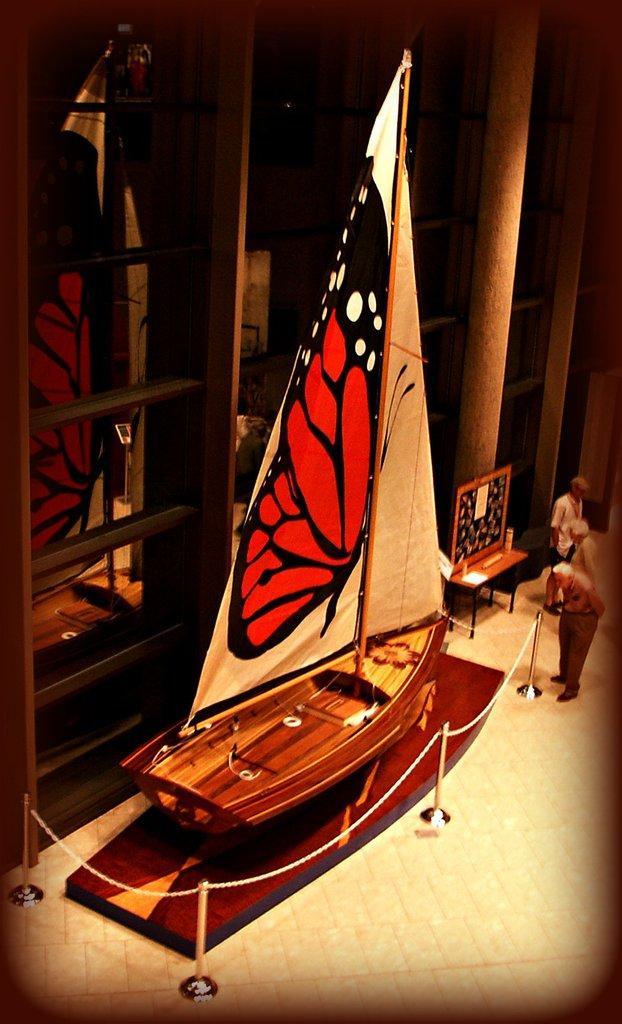How would you summarize this image in a sentence or two? In this image we can see one boat on the floor, one cloth with butterfly image attached to the boat, some poles with chain around the boat, three people standing, one poster attached to the board on the table, some objects on the table, one pillar, one mirror back side of the boat and some objects on the surface of the floor. 